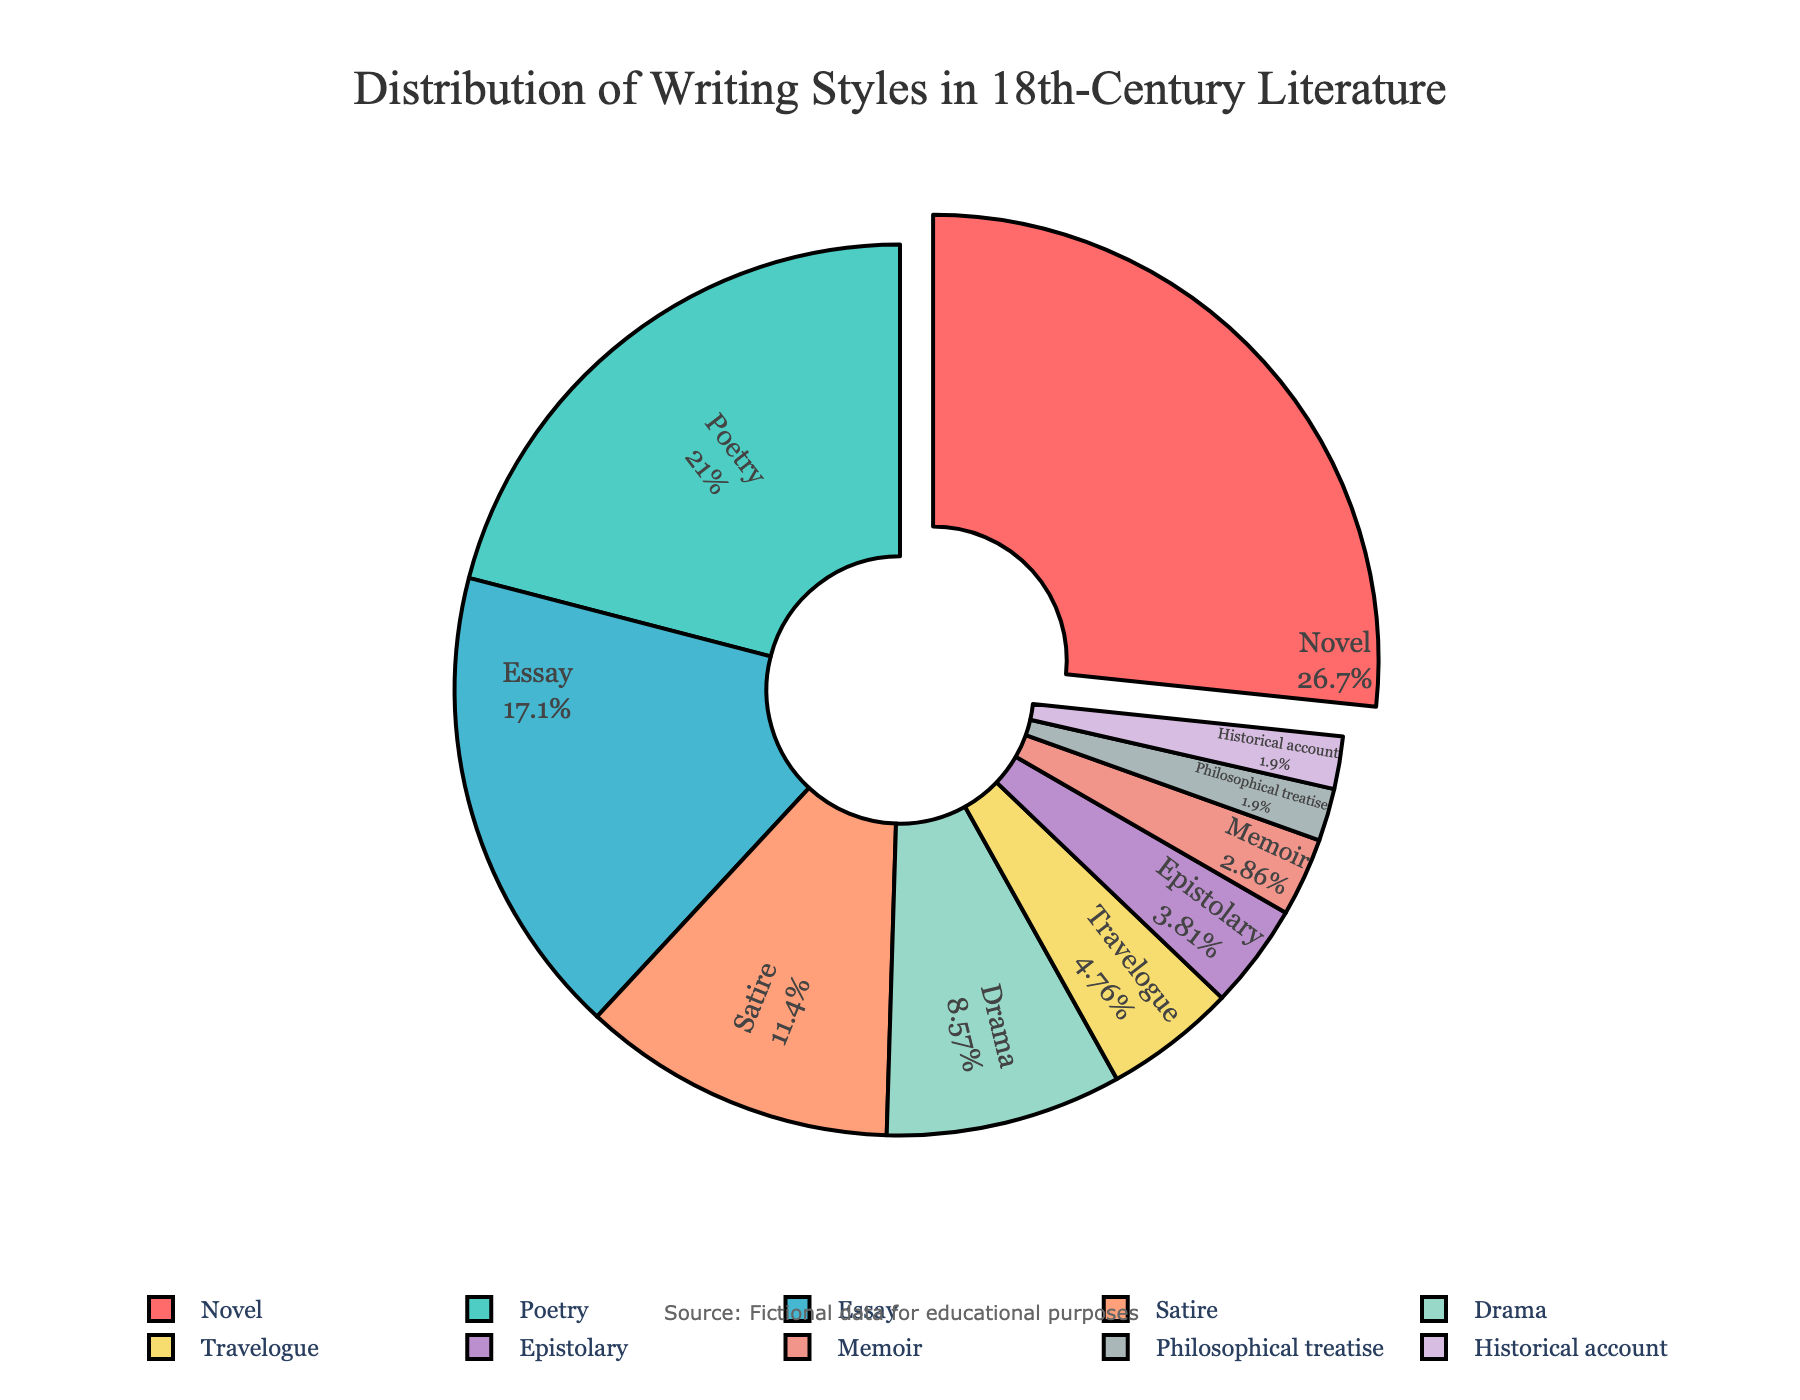Which genre has the largest percentage in the chart? The chart shows labels with their respective percentages, and the largest slice corresponds to the 'Novel' genre.
Answer: Novel What is the combined percentage of Poetry and Satire genres? The percentages for Poetry and Satire are 22% and 12% respectively. Adding them together gives 22% + 12% = 34%.
Answer: 34% Is the percentage of Drama greater than that of Travelogue? According to the chart, Drama has a percentage of 9% and Travelogue has 5%. Since 9% is greater than 5%, Drama has a higher percentage.
Answer: Yes Which genre makes up less than 5% of the chart? The genres with percentages less than 5% are Epistolary (4%), Memoir (3%), Philosophical treatise (2%), Historical account (2%).
Answer: Epistolary, Memoir, Philosophical treatise, Historical account What is the combined percentage of all genres making up less than 10%? Adding the percentages of genres with less than 10%: Satire (12%) + Drama (9%) + Travelogue (5%) + Epistolary (4%) + Memoir (3%) + Philosophical treatise (2%) + Historical account (2%) gives a total of 37%.
Answer: 37% Which genre is represented by the color red in the chart? Observing the chart, the largest slice (Novel) is marked with a red color.
Answer: Novel How much larger is the percentage of Essays compared to Drama? The percentage for Essays is 18%, and for Drama, it is 9%. The difference is 18% - 9% = 9%.
Answer: 9% What is the percentage difference between the smallest genre and the largest genre? The smallest genre, with a percentage of 2%, is either Philosophical treatise or Historical account, and the largest genre is Novel with 28%. The difference is 28% - 2% = 26%.
Answer: 26% What percentage do the top three genres together represent? The top three genres are Novel (28%), Poetry (22%), and Essay (18%). Adding these together gives 28% + 22% + 18% = 68%.
Answer: 68% Which genre occupies the smallest slice in the chart? The smallest percentages are 2%, and both Philosophical treatise and Historical account share this value.
Answer: Philosophical treatise, Historical account 